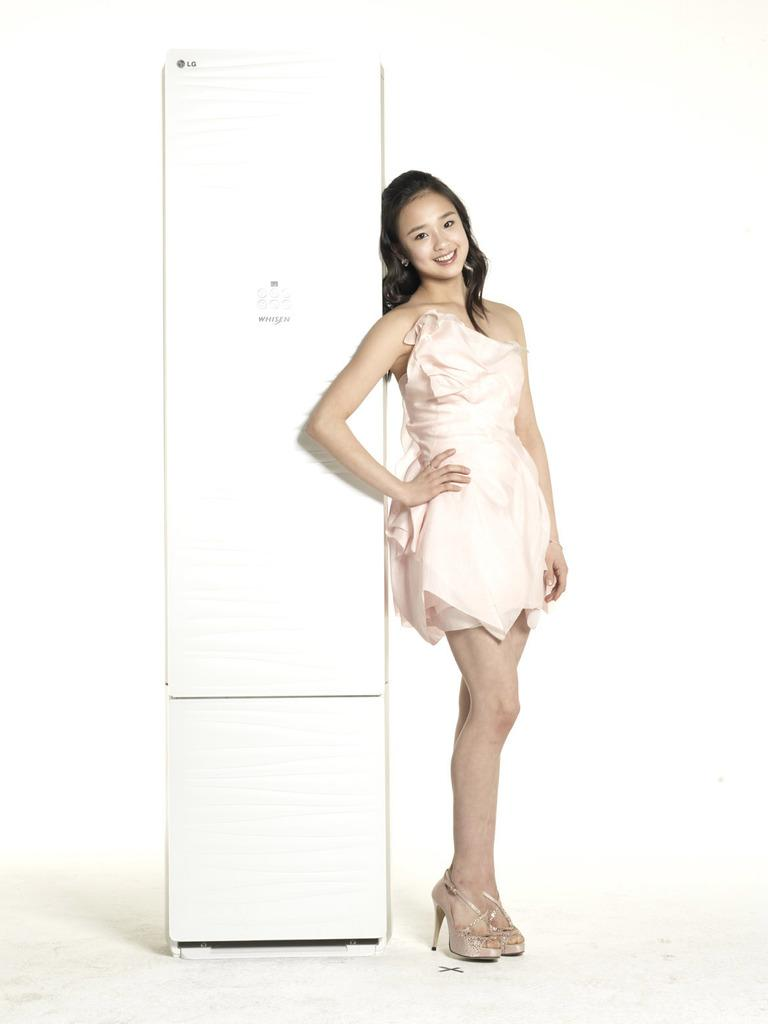Who is present in the image? There is a woman in the image. What is the woman doing in the image? The woman is standing on the floor. What object is located beside the woman? There is a refrigerator beside the woman. Can you see any icicles hanging from the refrigerator in the image? There are no icicles visible in the image; it is indoors and not cold enough for icicles to form. What type of dinner is the woman preparing in the image? There is no indication in the image that the woman is preparing dinner, as the facts provided do not mention any food or cooking activity. 